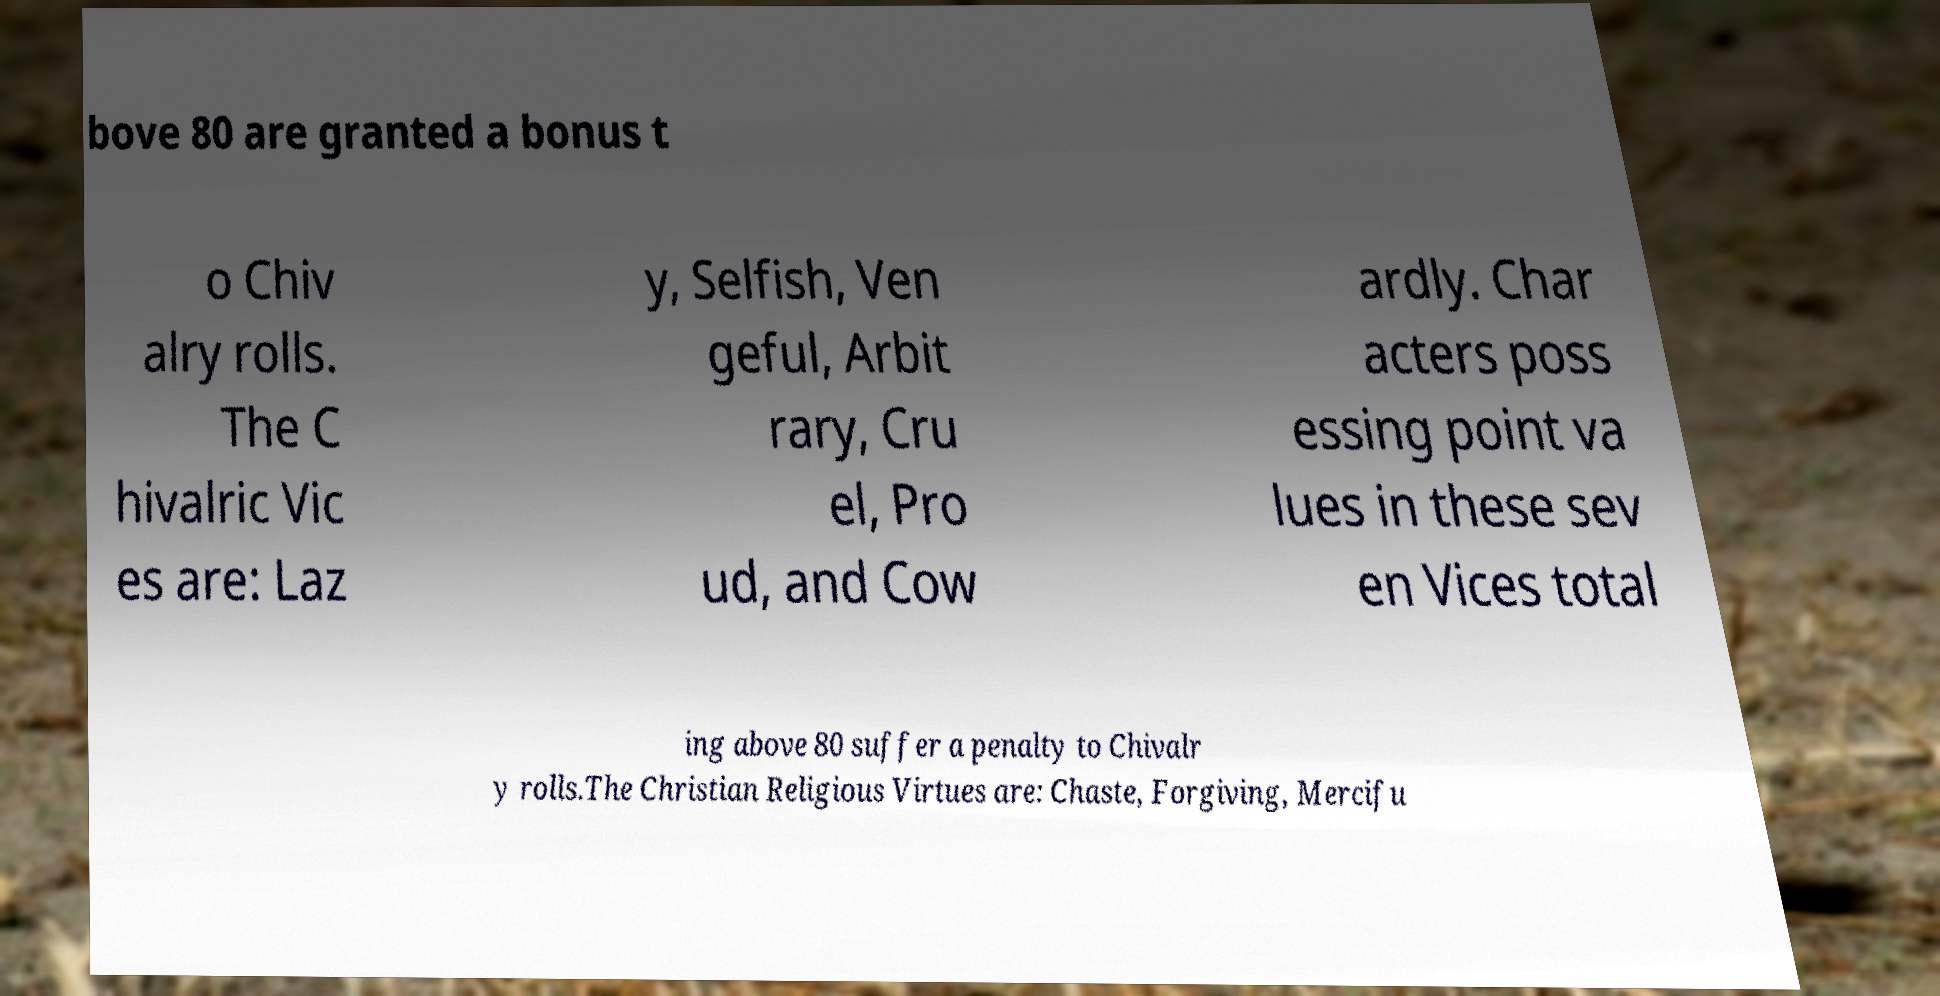For documentation purposes, I need the text within this image transcribed. Could you provide that? bove 80 are granted a bonus t o Chiv alry rolls. The C hivalric Vic es are: Laz y, Selfish, Ven geful, Arbit rary, Cru el, Pro ud, and Cow ardly. Char acters poss essing point va lues in these sev en Vices total ing above 80 suffer a penalty to Chivalr y rolls.The Christian Religious Virtues are: Chaste, Forgiving, Mercifu 